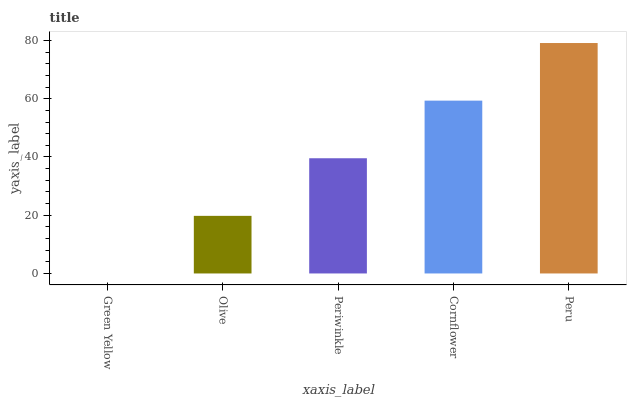Is Green Yellow the minimum?
Answer yes or no. Yes. Is Peru the maximum?
Answer yes or no. Yes. Is Olive the minimum?
Answer yes or no. No. Is Olive the maximum?
Answer yes or no. No. Is Olive greater than Green Yellow?
Answer yes or no. Yes. Is Green Yellow less than Olive?
Answer yes or no. Yes. Is Green Yellow greater than Olive?
Answer yes or no. No. Is Olive less than Green Yellow?
Answer yes or no. No. Is Periwinkle the high median?
Answer yes or no. Yes. Is Periwinkle the low median?
Answer yes or no. Yes. Is Olive the high median?
Answer yes or no. No. Is Peru the low median?
Answer yes or no. No. 